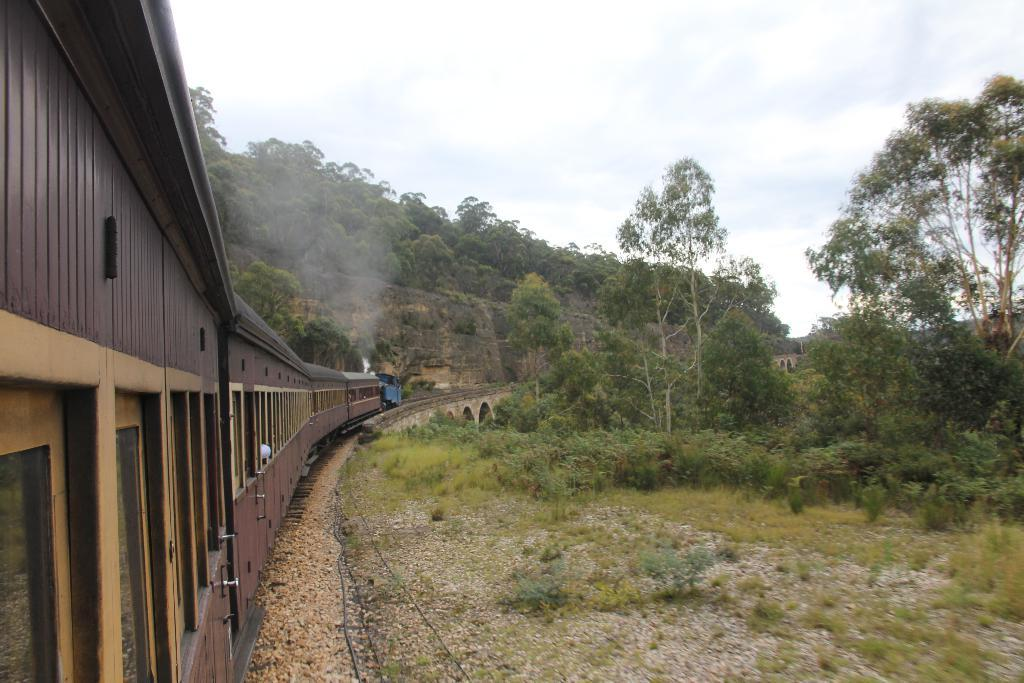What is located on the left side of the image? There is a train on the left side of the image. What is in front of the train? There is a hill in front of the train. What can be seen on the hill? Trees are present on the hill. What type of vegetation is on the right side of the image? There are trees and plants on the right side of the image. What is visible in the image besides the train and vegetation? The sky is visible in the image, and clouds are present in the sky. Can you hear the bear's voice in the image? There is no bear present in the image, and therefore no voice to hear. 